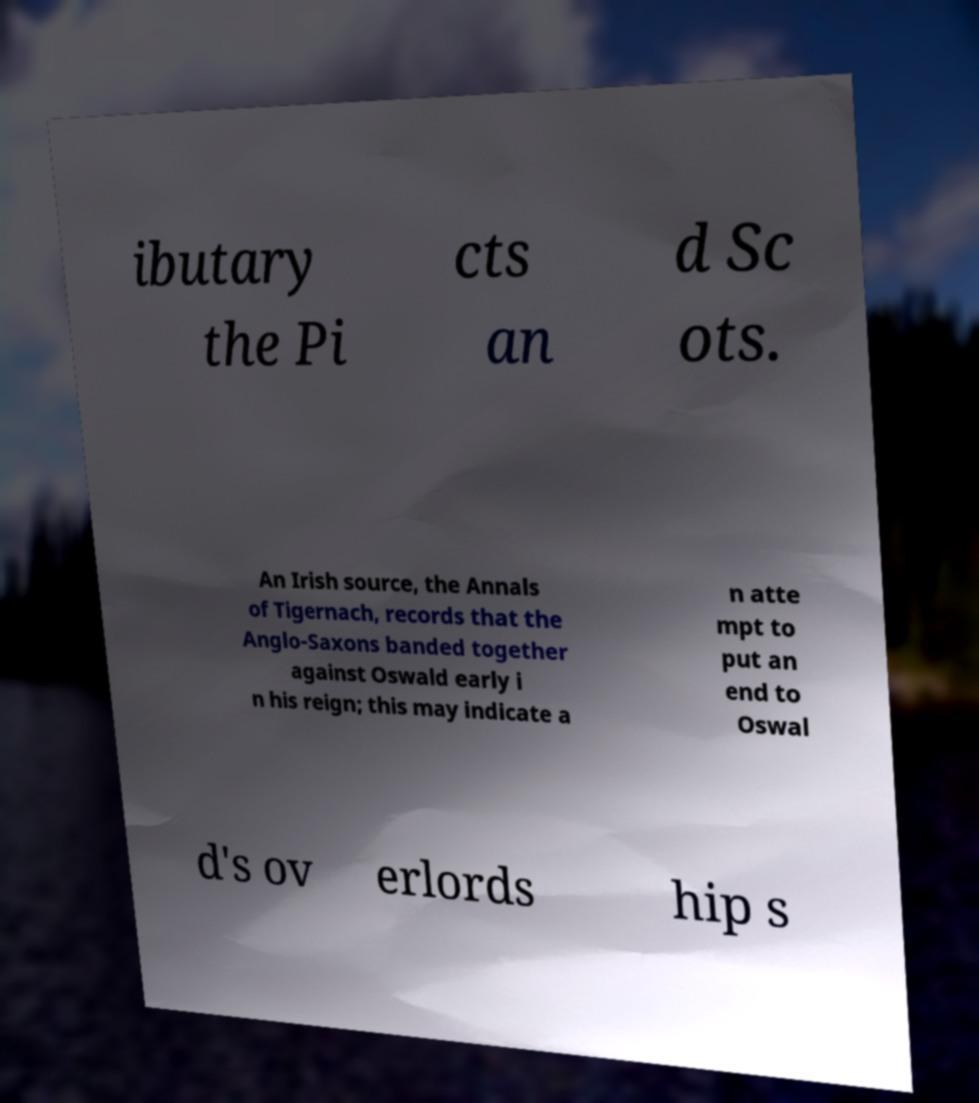Could you extract and type out the text from this image? ibutary the Pi cts an d Sc ots. An Irish source, the Annals of Tigernach, records that the Anglo-Saxons banded together against Oswald early i n his reign; this may indicate a n atte mpt to put an end to Oswal d's ov erlords hip s 